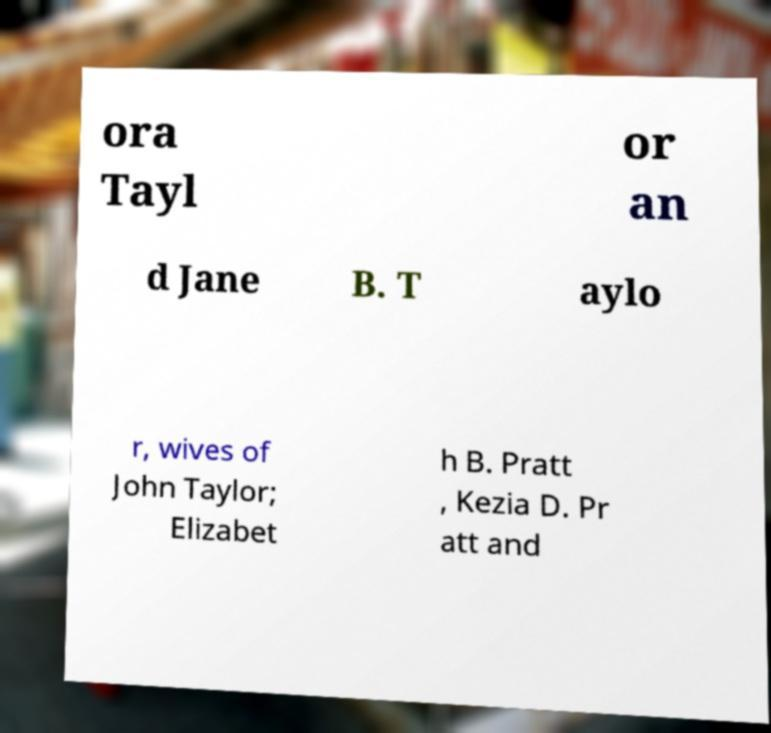Please identify and transcribe the text found in this image. ora Tayl or an d Jane B. T aylo r, wives of John Taylor; Elizabet h B. Pratt , Kezia D. Pr att and 